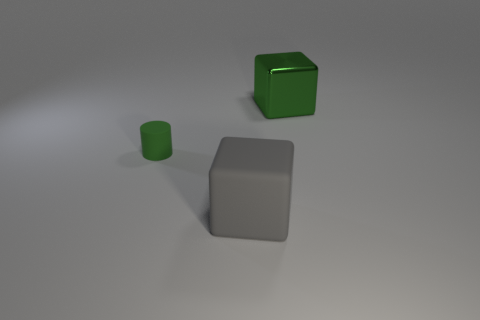What size is the object that is the same color as the matte cylinder? The cylinder is matte green, and the object sharing its color is the cube, which appears to be large compared to the cylinder. 